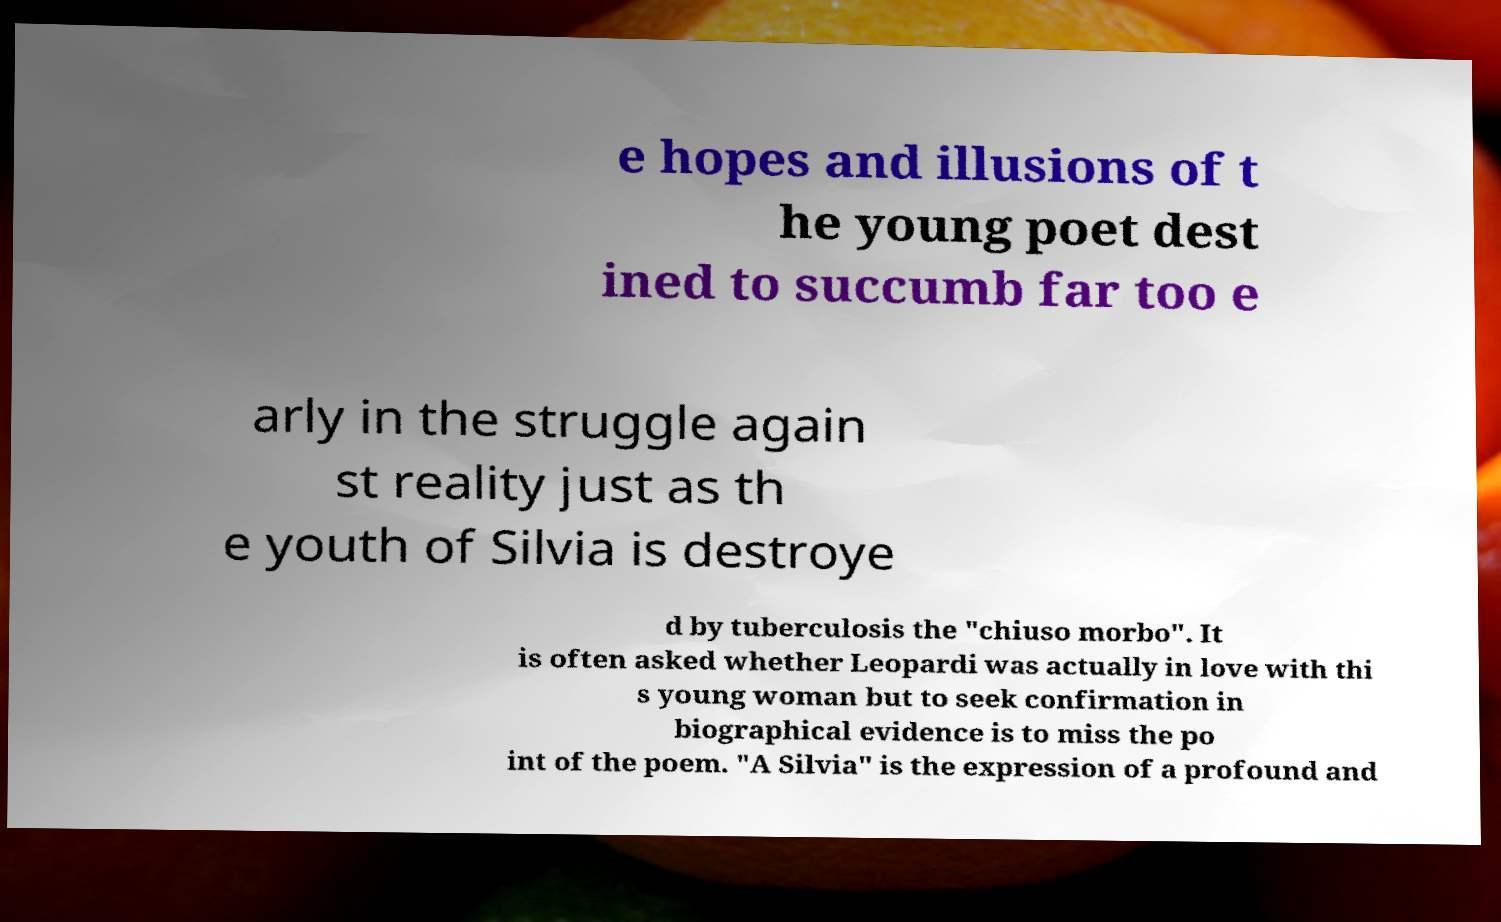For documentation purposes, I need the text within this image transcribed. Could you provide that? e hopes and illusions of t he young poet dest ined to succumb far too e arly in the struggle again st reality just as th e youth of Silvia is destroye d by tuberculosis the "chiuso morbo". It is often asked whether Leopardi was actually in love with thi s young woman but to seek confirmation in biographical evidence is to miss the po int of the poem. "A Silvia" is the expression of a profound and 